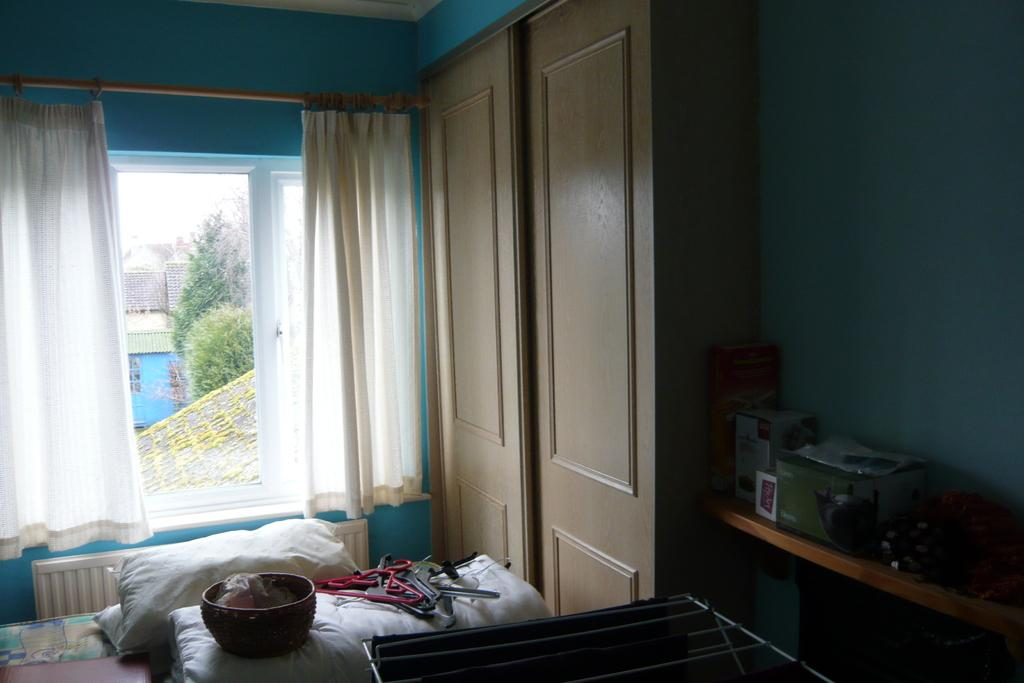What objects can be seen in the foreground area of the image? In the foreground area of the image, there are pillows, hangers, and cupboards. What can be found in the background of the image? In the background of the image, there are curtains, windows, houses, and trees. How many types of objects are present in the foreground area of the image? There are three types of objects in the foreground area of the image: pillows, hangers, and cupboards. What flavor of coil is present in the image? There is no coil present in the image, and therefore no flavor can be determined. What type of balloon can be seen in the image? There is no balloon present in the image. 